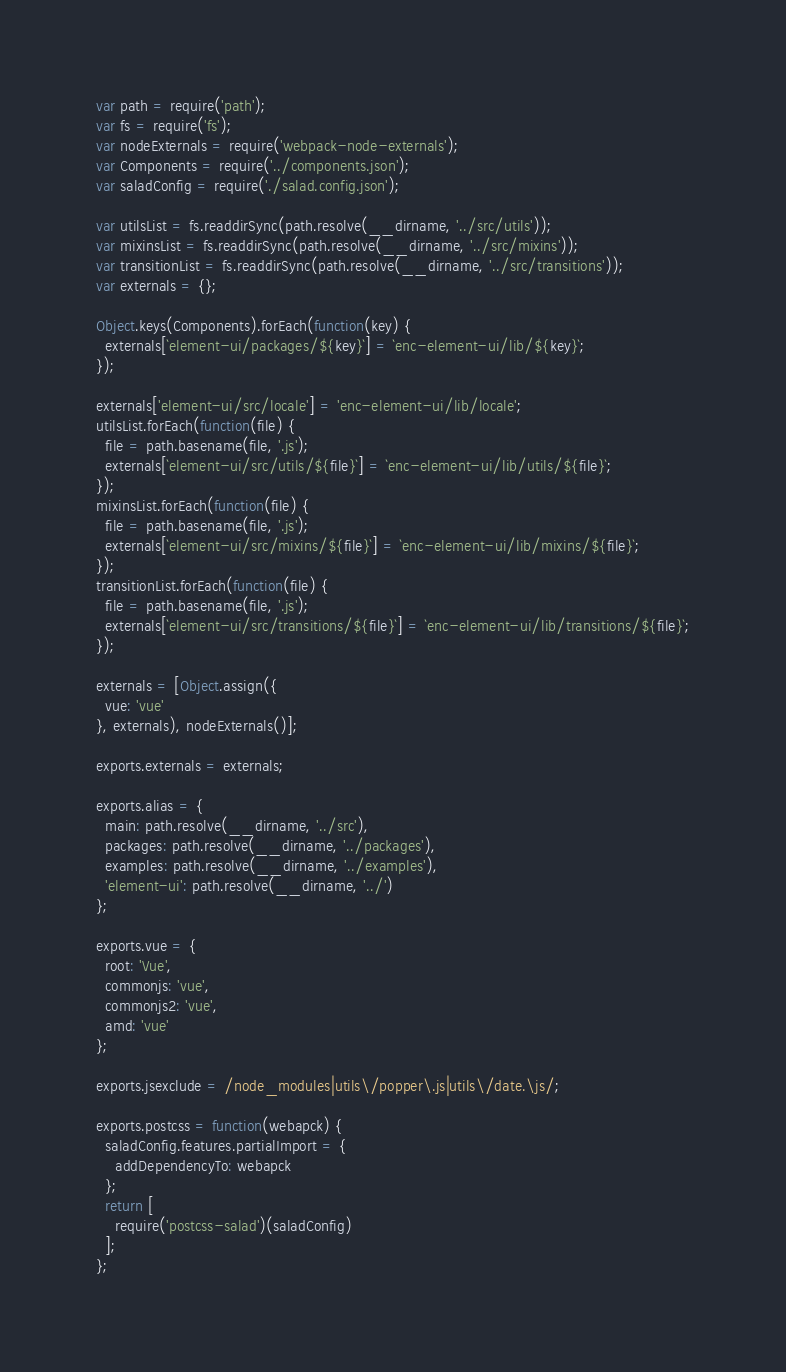Convert code to text. <code><loc_0><loc_0><loc_500><loc_500><_JavaScript_>var path = require('path');
var fs = require('fs');
var nodeExternals = require('webpack-node-externals');
var Components = require('../components.json');
var saladConfig = require('./salad.config.json');

var utilsList = fs.readdirSync(path.resolve(__dirname, '../src/utils'));
var mixinsList = fs.readdirSync(path.resolve(__dirname, '../src/mixins'));
var transitionList = fs.readdirSync(path.resolve(__dirname, '../src/transitions'));
var externals = {};

Object.keys(Components).forEach(function(key) {
  externals[`element-ui/packages/${key}`] = `enc-element-ui/lib/${key}`;
});

externals['element-ui/src/locale'] = 'enc-element-ui/lib/locale';
utilsList.forEach(function(file) {
  file = path.basename(file, '.js');
  externals[`element-ui/src/utils/${file}`] = `enc-element-ui/lib/utils/${file}`;
});
mixinsList.forEach(function(file) {
  file = path.basename(file, '.js');
  externals[`element-ui/src/mixins/${file}`] = `enc-element-ui/lib/mixins/${file}`;
});
transitionList.forEach(function(file) {
  file = path.basename(file, '.js');
  externals[`element-ui/src/transitions/${file}`] = `enc-element-ui/lib/transitions/${file}`;
});

externals = [Object.assign({
  vue: 'vue'
}, externals), nodeExternals()];

exports.externals = externals;

exports.alias = {
  main: path.resolve(__dirname, '../src'),
  packages: path.resolve(__dirname, '../packages'),
  examples: path.resolve(__dirname, '../examples'),
  'element-ui': path.resolve(__dirname, '../')
};

exports.vue = {
  root: 'Vue',
  commonjs: 'vue',
  commonjs2: 'vue',
  amd: 'vue'
};

exports.jsexclude = /node_modules|utils\/popper\.js|utils\/date.\js/;

exports.postcss = function(webapck) {
  saladConfig.features.partialImport = {
    addDependencyTo: webapck
  };
  return [
    require('postcss-salad')(saladConfig)
  ];
};
</code> 